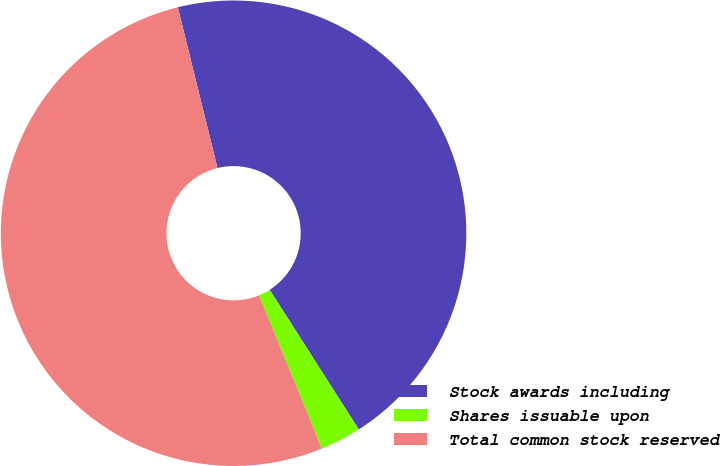Convert chart to OTSL. <chart><loc_0><loc_0><loc_500><loc_500><pie_chart><fcel>Stock awards including<fcel>Shares issuable upon<fcel>Total common stock reserved<nl><fcel>44.81%<fcel>2.84%<fcel>52.35%<nl></chart> 